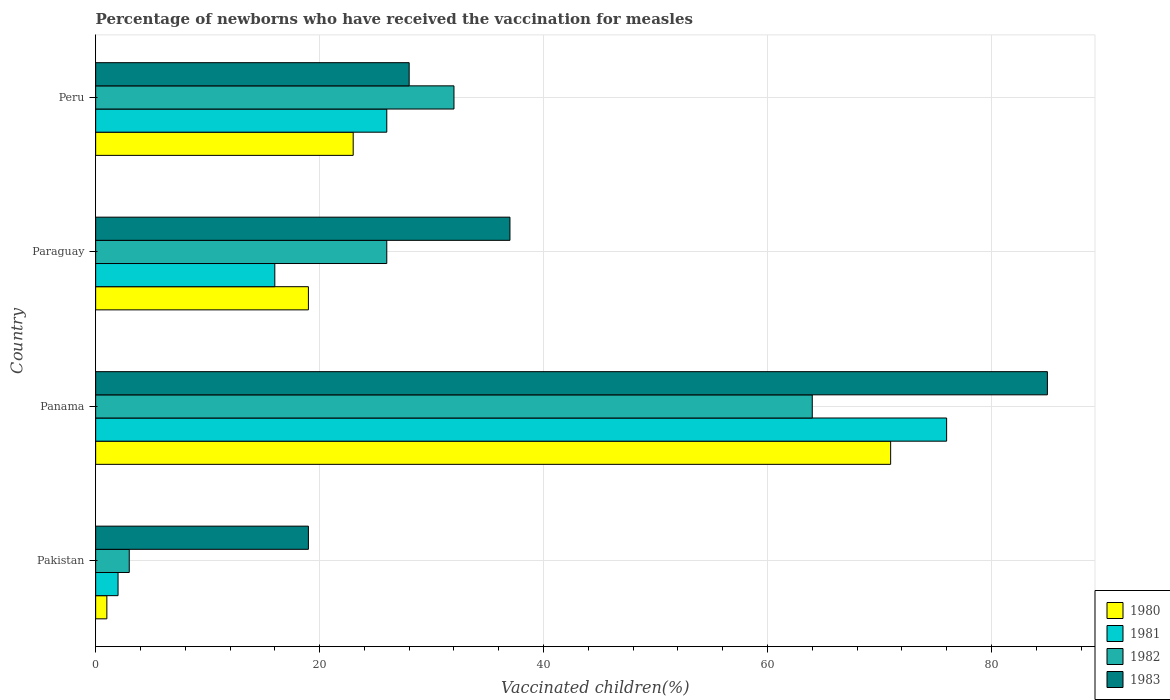How many groups of bars are there?
Your response must be concise. 4. Are the number of bars per tick equal to the number of legend labels?
Your answer should be very brief. Yes. How many bars are there on the 2nd tick from the top?
Ensure brevity in your answer.  4. How many bars are there on the 4th tick from the bottom?
Provide a short and direct response. 4. What is the label of the 4th group of bars from the top?
Offer a very short reply. Pakistan. In how many cases, is the number of bars for a given country not equal to the number of legend labels?
Make the answer very short. 0. Across all countries, what is the maximum percentage of vaccinated children in 1981?
Give a very brief answer. 76. Across all countries, what is the minimum percentage of vaccinated children in 1981?
Offer a terse response. 2. In which country was the percentage of vaccinated children in 1983 maximum?
Your answer should be very brief. Panama. What is the total percentage of vaccinated children in 1980 in the graph?
Keep it short and to the point. 114. What is the difference between the percentage of vaccinated children in 1980 in Pakistan and that in Peru?
Your answer should be very brief. -22. What is the difference between the percentage of vaccinated children in 1981 in Pakistan and the percentage of vaccinated children in 1980 in Peru?
Give a very brief answer. -21. What is the average percentage of vaccinated children in 1981 per country?
Ensure brevity in your answer.  30. What is the difference between the percentage of vaccinated children in 1983 and percentage of vaccinated children in 1981 in Panama?
Your answer should be compact. 9. In how many countries, is the percentage of vaccinated children in 1980 greater than 64 %?
Provide a short and direct response. 1. What is the ratio of the percentage of vaccinated children in 1983 in Pakistan to that in Peru?
Offer a terse response. 0.68. Is the percentage of vaccinated children in 1980 in Panama less than that in Peru?
Give a very brief answer. No. What is the difference between the highest and the second highest percentage of vaccinated children in 1980?
Your answer should be very brief. 48. What is the difference between the highest and the lowest percentage of vaccinated children in 1981?
Your answer should be compact. 74. What does the 4th bar from the top in Panama represents?
Offer a very short reply. 1980. Is it the case that in every country, the sum of the percentage of vaccinated children in 1981 and percentage of vaccinated children in 1982 is greater than the percentage of vaccinated children in 1980?
Your response must be concise. Yes. How many bars are there?
Offer a terse response. 16. Are all the bars in the graph horizontal?
Offer a very short reply. Yes. How many countries are there in the graph?
Provide a short and direct response. 4. Are the values on the major ticks of X-axis written in scientific E-notation?
Your answer should be very brief. No. Does the graph contain any zero values?
Offer a terse response. No. How are the legend labels stacked?
Offer a very short reply. Vertical. What is the title of the graph?
Offer a terse response. Percentage of newborns who have received the vaccination for measles. What is the label or title of the X-axis?
Your response must be concise. Vaccinated children(%). What is the Vaccinated children(%) in 1980 in Pakistan?
Ensure brevity in your answer.  1. What is the Vaccinated children(%) of 1981 in Pakistan?
Offer a very short reply. 2. What is the Vaccinated children(%) of 1983 in Pakistan?
Offer a terse response. 19. What is the Vaccinated children(%) of 1980 in Panama?
Provide a short and direct response. 71. What is the Vaccinated children(%) of 1982 in Panama?
Provide a succinct answer. 64. What is the Vaccinated children(%) in 1983 in Panama?
Your response must be concise. 85. What is the Vaccinated children(%) in 1980 in Paraguay?
Your response must be concise. 19. What is the Vaccinated children(%) of 1982 in Paraguay?
Give a very brief answer. 26. Across all countries, what is the maximum Vaccinated children(%) of 1982?
Ensure brevity in your answer.  64. Across all countries, what is the minimum Vaccinated children(%) in 1983?
Provide a succinct answer. 19. What is the total Vaccinated children(%) of 1980 in the graph?
Make the answer very short. 114. What is the total Vaccinated children(%) in 1981 in the graph?
Your response must be concise. 120. What is the total Vaccinated children(%) in 1982 in the graph?
Offer a very short reply. 125. What is the total Vaccinated children(%) in 1983 in the graph?
Make the answer very short. 169. What is the difference between the Vaccinated children(%) in 1980 in Pakistan and that in Panama?
Give a very brief answer. -70. What is the difference between the Vaccinated children(%) of 1981 in Pakistan and that in Panama?
Offer a very short reply. -74. What is the difference between the Vaccinated children(%) of 1982 in Pakistan and that in Panama?
Provide a short and direct response. -61. What is the difference between the Vaccinated children(%) in 1983 in Pakistan and that in Panama?
Provide a short and direct response. -66. What is the difference between the Vaccinated children(%) in 1980 in Pakistan and that in Peru?
Provide a succinct answer. -22. What is the difference between the Vaccinated children(%) in 1981 in Pakistan and that in Peru?
Offer a terse response. -24. What is the difference between the Vaccinated children(%) of 1981 in Panama and that in Paraguay?
Your response must be concise. 60. What is the difference between the Vaccinated children(%) of 1980 in Panama and that in Peru?
Your answer should be very brief. 48. What is the difference between the Vaccinated children(%) of 1981 in Panama and that in Peru?
Keep it short and to the point. 50. What is the difference between the Vaccinated children(%) in 1983 in Panama and that in Peru?
Your answer should be very brief. 57. What is the difference between the Vaccinated children(%) in 1981 in Paraguay and that in Peru?
Make the answer very short. -10. What is the difference between the Vaccinated children(%) in 1982 in Paraguay and that in Peru?
Your answer should be compact. -6. What is the difference between the Vaccinated children(%) of 1983 in Paraguay and that in Peru?
Offer a very short reply. 9. What is the difference between the Vaccinated children(%) of 1980 in Pakistan and the Vaccinated children(%) of 1981 in Panama?
Provide a succinct answer. -75. What is the difference between the Vaccinated children(%) of 1980 in Pakistan and the Vaccinated children(%) of 1982 in Panama?
Give a very brief answer. -63. What is the difference between the Vaccinated children(%) in 1980 in Pakistan and the Vaccinated children(%) in 1983 in Panama?
Ensure brevity in your answer.  -84. What is the difference between the Vaccinated children(%) in 1981 in Pakistan and the Vaccinated children(%) in 1982 in Panama?
Give a very brief answer. -62. What is the difference between the Vaccinated children(%) of 1981 in Pakistan and the Vaccinated children(%) of 1983 in Panama?
Provide a succinct answer. -83. What is the difference between the Vaccinated children(%) in 1982 in Pakistan and the Vaccinated children(%) in 1983 in Panama?
Offer a terse response. -82. What is the difference between the Vaccinated children(%) of 1980 in Pakistan and the Vaccinated children(%) of 1981 in Paraguay?
Keep it short and to the point. -15. What is the difference between the Vaccinated children(%) of 1980 in Pakistan and the Vaccinated children(%) of 1982 in Paraguay?
Your response must be concise. -25. What is the difference between the Vaccinated children(%) in 1980 in Pakistan and the Vaccinated children(%) in 1983 in Paraguay?
Provide a short and direct response. -36. What is the difference between the Vaccinated children(%) in 1981 in Pakistan and the Vaccinated children(%) in 1983 in Paraguay?
Your response must be concise. -35. What is the difference between the Vaccinated children(%) in 1982 in Pakistan and the Vaccinated children(%) in 1983 in Paraguay?
Provide a short and direct response. -34. What is the difference between the Vaccinated children(%) of 1980 in Pakistan and the Vaccinated children(%) of 1981 in Peru?
Provide a short and direct response. -25. What is the difference between the Vaccinated children(%) in 1980 in Pakistan and the Vaccinated children(%) in 1982 in Peru?
Offer a terse response. -31. What is the difference between the Vaccinated children(%) of 1982 in Pakistan and the Vaccinated children(%) of 1983 in Peru?
Your answer should be compact. -25. What is the difference between the Vaccinated children(%) of 1980 in Panama and the Vaccinated children(%) of 1982 in Paraguay?
Offer a very short reply. 45. What is the difference between the Vaccinated children(%) in 1980 in Panama and the Vaccinated children(%) in 1981 in Peru?
Offer a very short reply. 45. What is the difference between the Vaccinated children(%) of 1980 in Panama and the Vaccinated children(%) of 1983 in Peru?
Keep it short and to the point. 43. What is the difference between the Vaccinated children(%) of 1980 in Paraguay and the Vaccinated children(%) of 1981 in Peru?
Your response must be concise. -7. What is the difference between the Vaccinated children(%) of 1980 in Paraguay and the Vaccinated children(%) of 1983 in Peru?
Provide a succinct answer. -9. What is the difference between the Vaccinated children(%) in 1981 in Paraguay and the Vaccinated children(%) in 1983 in Peru?
Keep it short and to the point. -12. What is the difference between the Vaccinated children(%) in 1982 in Paraguay and the Vaccinated children(%) in 1983 in Peru?
Your response must be concise. -2. What is the average Vaccinated children(%) in 1981 per country?
Your answer should be very brief. 30. What is the average Vaccinated children(%) of 1982 per country?
Your answer should be very brief. 31.25. What is the average Vaccinated children(%) of 1983 per country?
Offer a terse response. 42.25. What is the difference between the Vaccinated children(%) of 1981 and Vaccinated children(%) of 1982 in Pakistan?
Your response must be concise. -1. What is the difference between the Vaccinated children(%) of 1982 and Vaccinated children(%) of 1983 in Pakistan?
Ensure brevity in your answer.  -16. What is the difference between the Vaccinated children(%) in 1980 and Vaccinated children(%) in 1982 in Panama?
Keep it short and to the point. 7. What is the difference between the Vaccinated children(%) of 1981 and Vaccinated children(%) of 1982 in Panama?
Give a very brief answer. 12. What is the difference between the Vaccinated children(%) of 1981 and Vaccinated children(%) of 1983 in Panama?
Ensure brevity in your answer.  -9. What is the difference between the Vaccinated children(%) in 1982 and Vaccinated children(%) in 1983 in Panama?
Keep it short and to the point. -21. What is the difference between the Vaccinated children(%) of 1980 and Vaccinated children(%) of 1982 in Peru?
Your response must be concise. -9. What is the difference between the Vaccinated children(%) of 1981 and Vaccinated children(%) of 1982 in Peru?
Your answer should be compact. -6. What is the difference between the Vaccinated children(%) of 1981 and Vaccinated children(%) of 1983 in Peru?
Provide a succinct answer. -2. What is the ratio of the Vaccinated children(%) in 1980 in Pakistan to that in Panama?
Offer a terse response. 0.01. What is the ratio of the Vaccinated children(%) in 1981 in Pakistan to that in Panama?
Provide a short and direct response. 0.03. What is the ratio of the Vaccinated children(%) in 1982 in Pakistan to that in Panama?
Provide a short and direct response. 0.05. What is the ratio of the Vaccinated children(%) in 1983 in Pakistan to that in Panama?
Your response must be concise. 0.22. What is the ratio of the Vaccinated children(%) in 1980 in Pakistan to that in Paraguay?
Provide a short and direct response. 0.05. What is the ratio of the Vaccinated children(%) in 1981 in Pakistan to that in Paraguay?
Provide a short and direct response. 0.12. What is the ratio of the Vaccinated children(%) of 1982 in Pakistan to that in Paraguay?
Offer a very short reply. 0.12. What is the ratio of the Vaccinated children(%) in 1983 in Pakistan to that in Paraguay?
Your answer should be compact. 0.51. What is the ratio of the Vaccinated children(%) of 1980 in Pakistan to that in Peru?
Make the answer very short. 0.04. What is the ratio of the Vaccinated children(%) of 1981 in Pakistan to that in Peru?
Offer a terse response. 0.08. What is the ratio of the Vaccinated children(%) of 1982 in Pakistan to that in Peru?
Ensure brevity in your answer.  0.09. What is the ratio of the Vaccinated children(%) of 1983 in Pakistan to that in Peru?
Make the answer very short. 0.68. What is the ratio of the Vaccinated children(%) in 1980 in Panama to that in Paraguay?
Offer a very short reply. 3.74. What is the ratio of the Vaccinated children(%) of 1981 in Panama to that in Paraguay?
Provide a succinct answer. 4.75. What is the ratio of the Vaccinated children(%) in 1982 in Panama to that in Paraguay?
Provide a succinct answer. 2.46. What is the ratio of the Vaccinated children(%) of 1983 in Panama to that in Paraguay?
Keep it short and to the point. 2.3. What is the ratio of the Vaccinated children(%) of 1980 in Panama to that in Peru?
Keep it short and to the point. 3.09. What is the ratio of the Vaccinated children(%) of 1981 in Panama to that in Peru?
Ensure brevity in your answer.  2.92. What is the ratio of the Vaccinated children(%) in 1983 in Panama to that in Peru?
Your response must be concise. 3.04. What is the ratio of the Vaccinated children(%) in 1980 in Paraguay to that in Peru?
Provide a short and direct response. 0.83. What is the ratio of the Vaccinated children(%) of 1981 in Paraguay to that in Peru?
Keep it short and to the point. 0.62. What is the ratio of the Vaccinated children(%) of 1982 in Paraguay to that in Peru?
Your answer should be very brief. 0.81. What is the ratio of the Vaccinated children(%) of 1983 in Paraguay to that in Peru?
Make the answer very short. 1.32. What is the difference between the highest and the second highest Vaccinated children(%) in 1983?
Provide a succinct answer. 48. What is the difference between the highest and the lowest Vaccinated children(%) in 1980?
Ensure brevity in your answer.  70. What is the difference between the highest and the lowest Vaccinated children(%) in 1983?
Give a very brief answer. 66. 